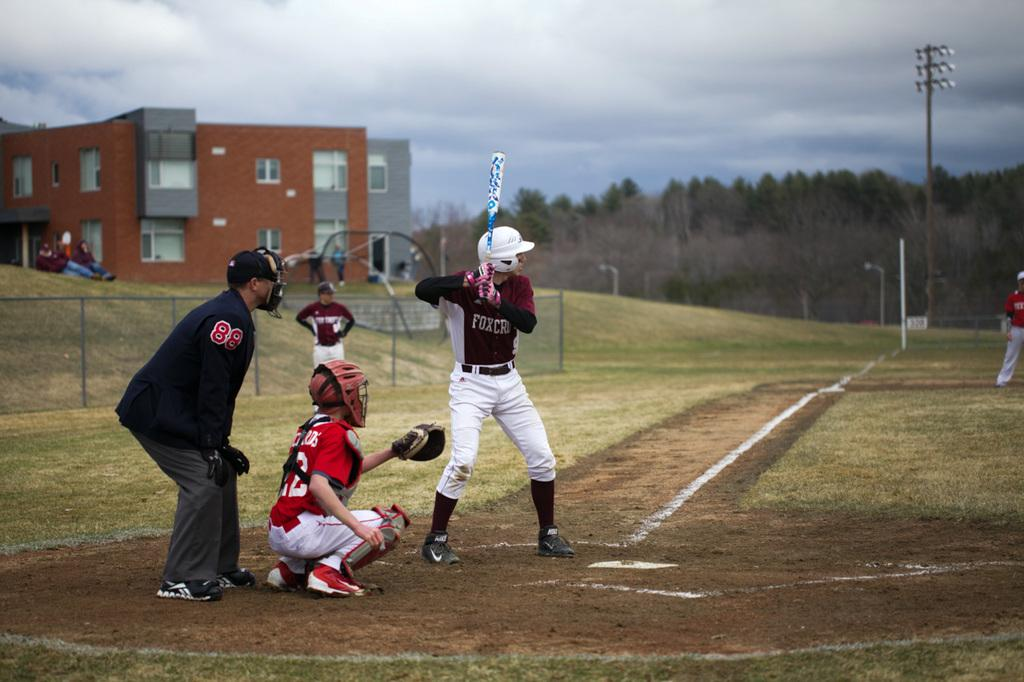<image>
Summarize the visual content of the image. A batter stands in the box, the umpire has the number 88 on his sleeve.. 